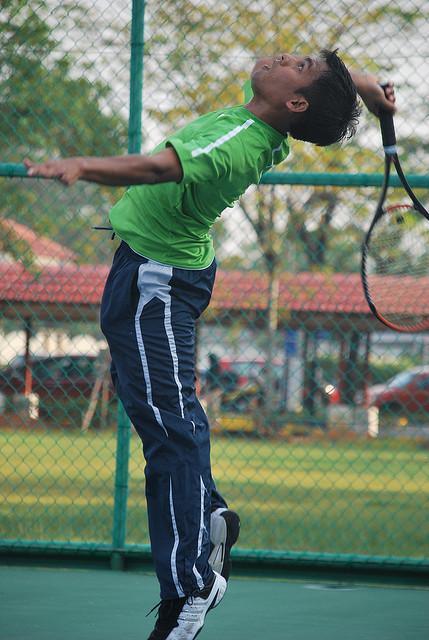How many cars are visible?
Give a very brief answer. 2. 